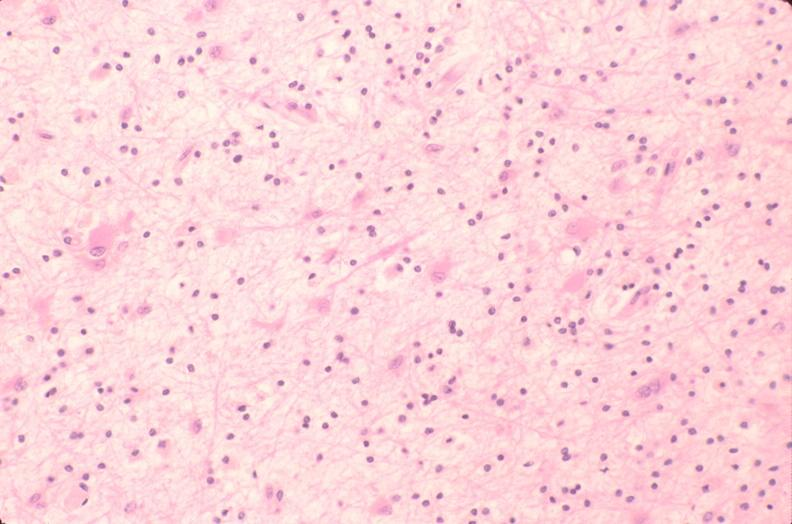s gangrene toe in infant present?
Answer the question using a single word or phrase. No 